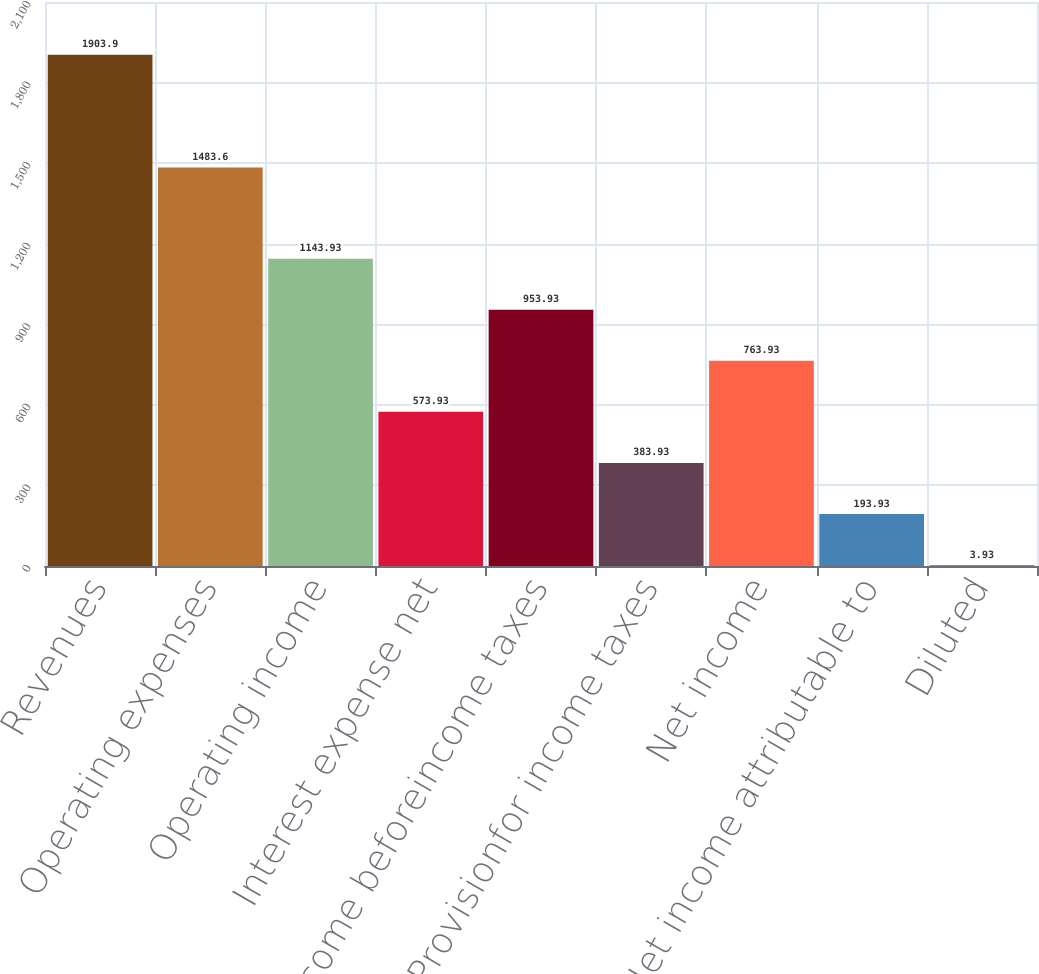<chart> <loc_0><loc_0><loc_500><loc_500><bar_chart><fcel>Revenues<fcel>Operating expenses<fcel>Operating income<fcel>Interest expense net<fcel>Income beforeincome taxes<fcel>Provisionfor income taxes<fcel>Net income<fcel>Net income attributable to<fcel>Diluted<nl><fcel>1903.9<fcel>1483.6<fcel>1143.93<fcel>573.93<fcel>953.93<fcel>383.93<fcel>763.93<fcel>193.93<fcel>3.93<nl></chart> 